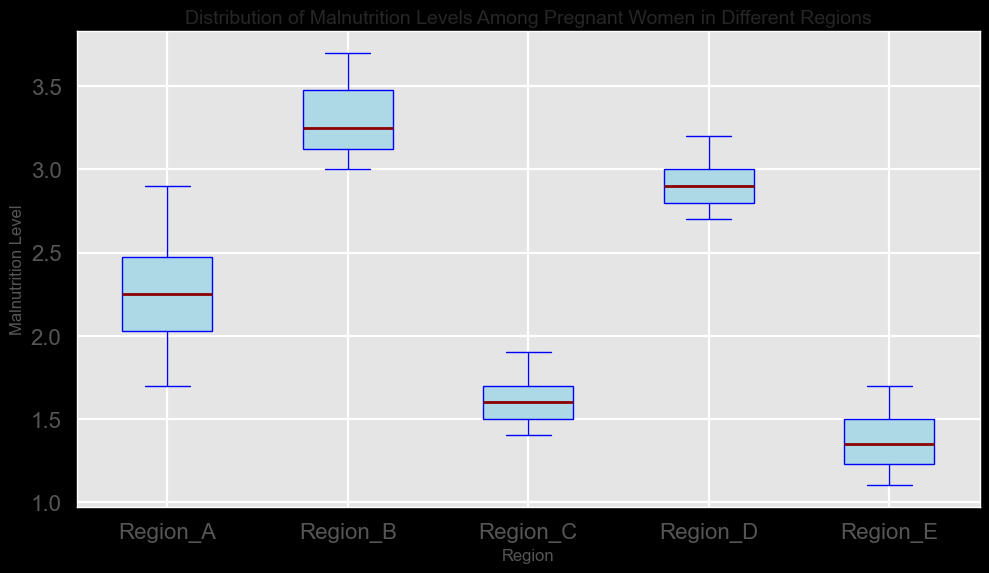Which region has the highest median malnutrition level? The box plot shows the median values with dark red lines inside the boxes. By visually inspecting the plots, Region B has the highest median line
Answer: Region B Which regions have the lowest and highest median malnutrition levels? By observing the dark red median lines, Region E has the lowest and Region B has the highest median malnutrition levels
Answer: Regions E and B What is the interquartile range (IQR) for Region A? The IQR is the difference between the upper quartile (75th percentile) and lower quartile (25th percentile). From the plot, the edges of the box for Region A represent these quartiles, approximately 2.6 - 2.0 = 0.6
Answer: 0.6 How does the spread of malnutrition levels in Region D compare to Region C? The spread can be assessed by the height of the boxes and the length of the whiskers. Region D has a larger box and longer whiskers compared to Region C, indicating a larger spread
Answer: Region D has a larger spread Is there any region with potential outliers? Outliers are usually represented as individual points outside the whiskers. From the plot, no regions display distinct individual points beyond the whiskers
Answer: No outliers Which region has the least variance in malnutrition levels? Variance can be visually assessed by the height of the box (IQR) and the length of the whiskers. The smallest box and shortest whiskers appear for Region E, indicating the least variance
Answer: Region E Compare the upper quartile values for Region A and Region D. The upper quartile is the top edge of the box. For Region A, it is approximately 2.6, and for Region D it is approximately 3.1
Answer: Region D has a higher upper quartile What is the approximate range of malnutrition levels in Region C? Range is the difference between the maximum and minimum values. Region C's whiskers extend from around 1.4 to 1.9, making the range approximately 1.9 - 1.4 = 0.5
Answer: 0.5 Which regions fall within the malnutrition levels of 2.0 to 3.0 for the majority of their data points? By observing the boxes and whiskers, Region A, Region D, and Region B include 2.0 to 3.0 within their interquartile ranges and whiskers
Answer: Regions A, D, B 